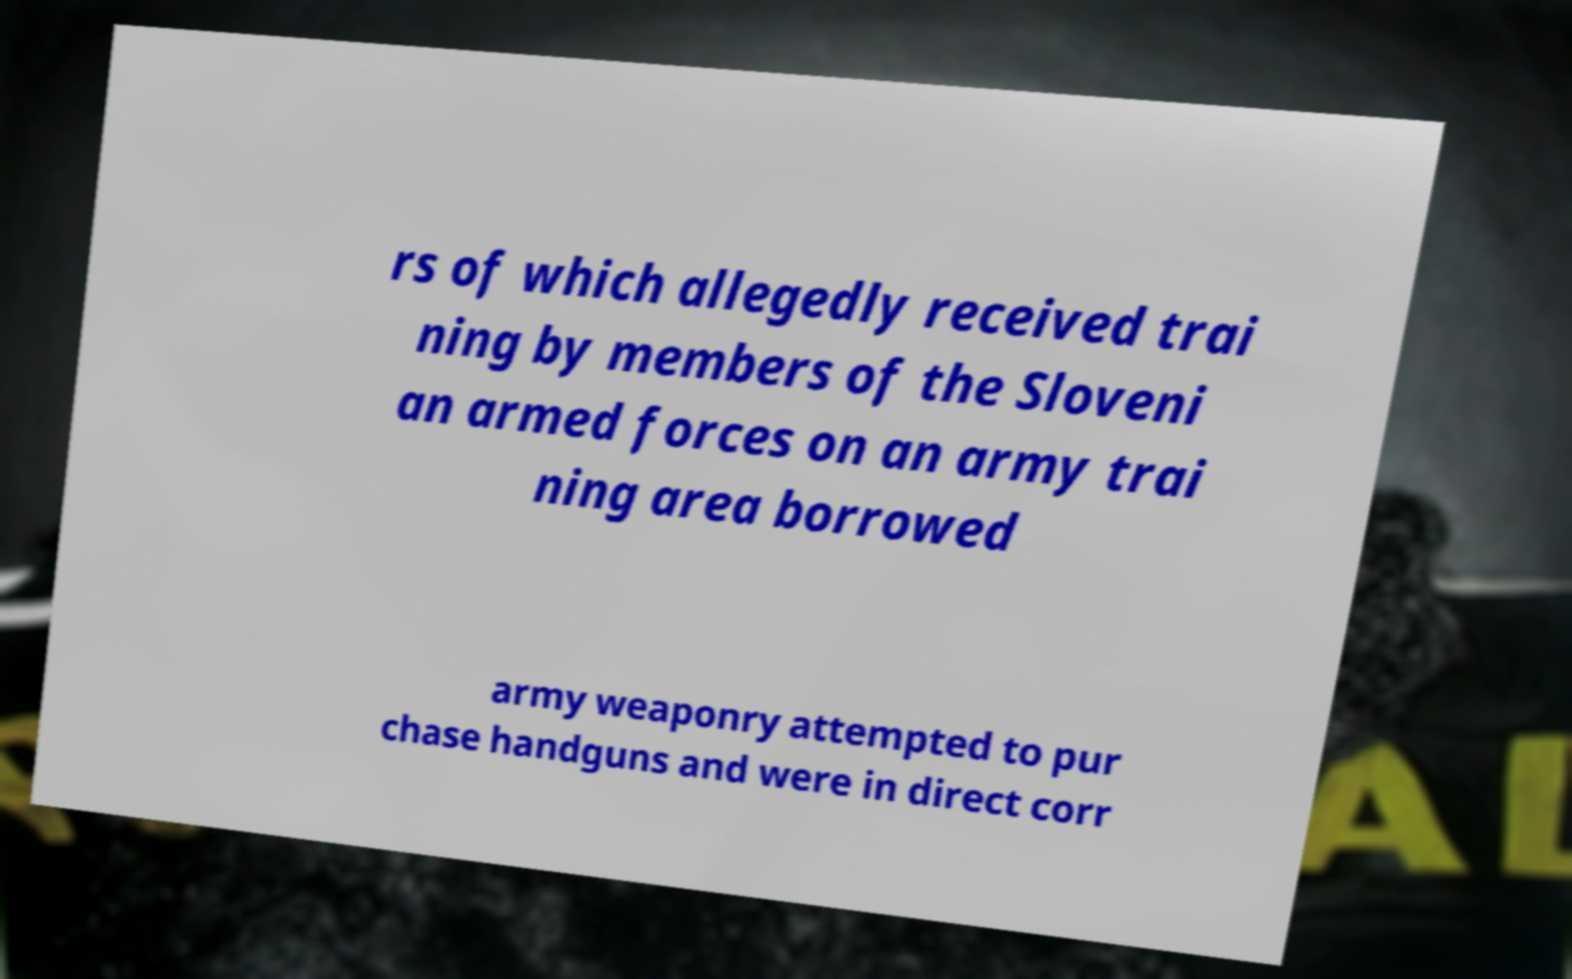I need the written content from this picture converted into text. Can you do that? rs of which allegedly received trai ning by members of the Sloveni an armed forces on an army trai ning area borrowed army weaponry attempted to pur chase handguns and were in direct corr 